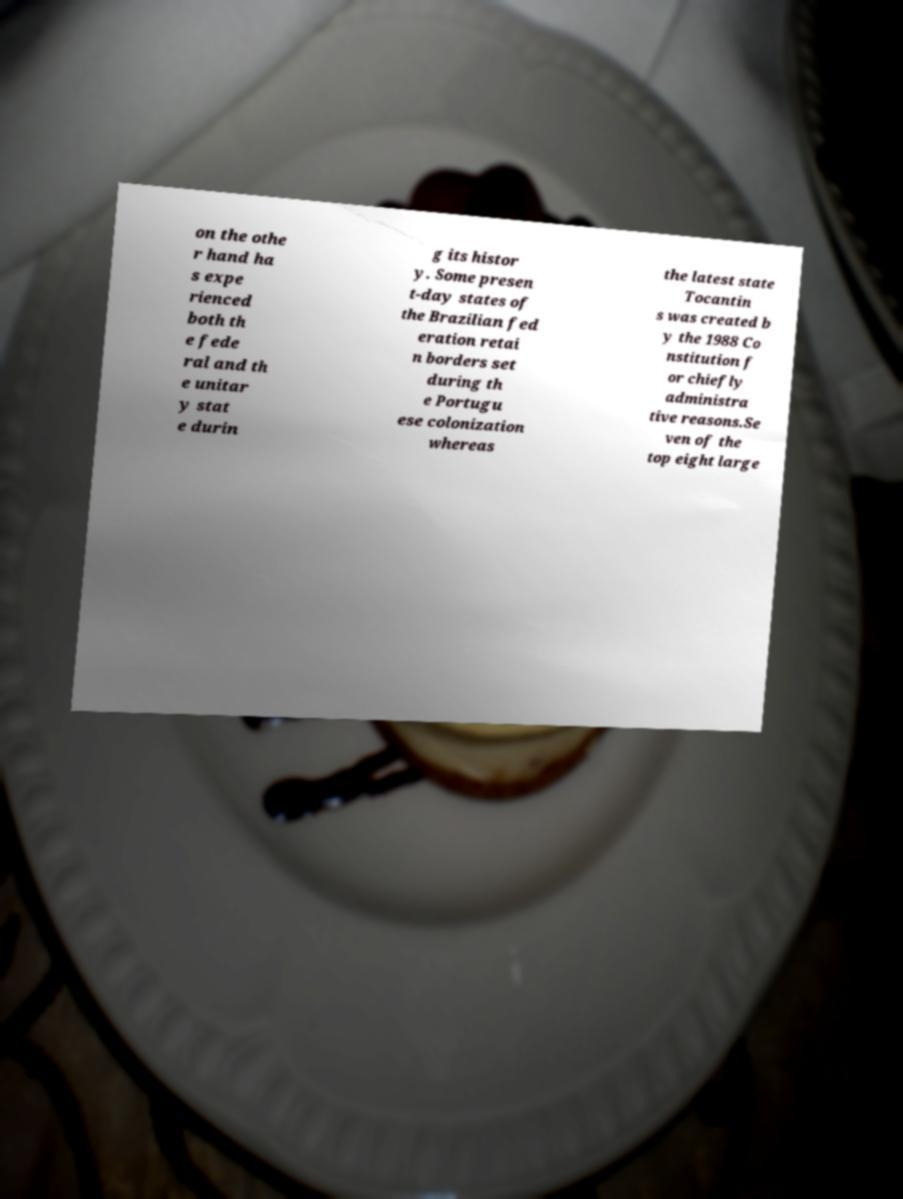For documentation purposes, I need the text within this image transcribed. Could you provide that? on the othe r hand ha s expe rienced both th e fede ral and th e unitar y stat e durin g its histor y. Some presen t-day states of the Brazilian fed eration retai n borders set during th e Portugu ese colonization whereas the latest state Tocantin s was created b y the 1988 Co nstitution f or chiefly administra tive reasons.Se ven of the top eight large 